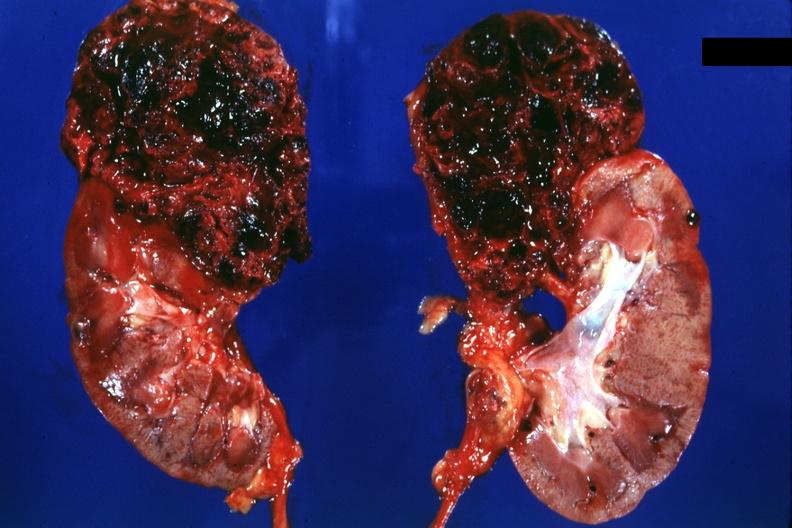where is this?
Answer the question using a single word or phrase. Urinary 